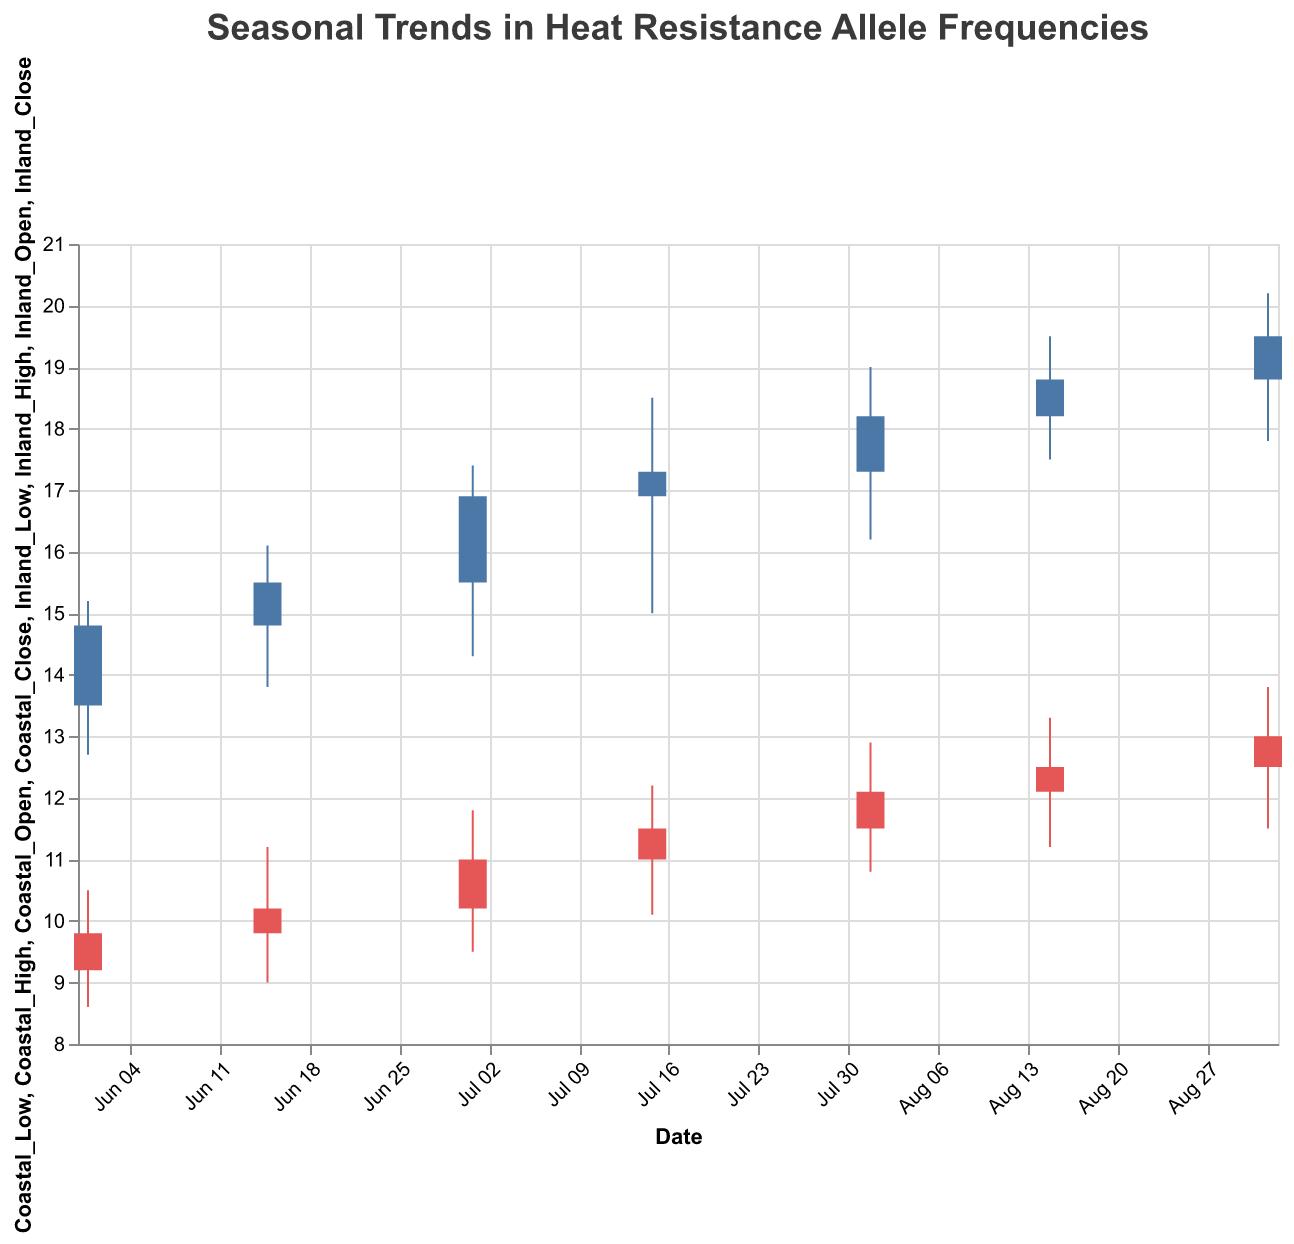What is the title of the figure? The title of the figure is often found at the top center and is designed to give an overview of what the graph represents. Here, the title reads "Seasonal Trends in Heat Resistance Allele Frequencies".
Answer: Seasonal Trends in Heat Resistance Allele Frequencies What colors are used to represent the coastal and inland fish populations? The figure uses different colors to visually distinguish between data sets. The coastal fish population data is represented in blue, and the inland fish population data is represented in red.
Answer: Blue for coastal, red for inland During which date did the coastal fish population have their highest closing value? To find the highest closing value for the coastal fish population, check the Coastal_Close column. The highest value is 19.5, which occurred on 2023-09-01.
Answer: 2023-09-01 What is the trend of allele frequencies in coastal fish from June 1st to September 1st? The coastal allele frequencies, represented by the closing values, show a continuous increase from 14.8 on June 1st to 19.5 on September 1st. This suggests a growing heat resistance over the period.
Answer: Increasing Compare the closing values between coastal and inland fish populations on September 1st. Which population has a higher allele frequency? On September 1st, the closing value for coastal fish is 19.5 and for inland fish is 13.0. Therefore, coastal fish have a higher allele frequency.
Answer: Coastal fish What’s the median closing value of the coastal fish population across all dates? To find the median value, list all the Coastal_Close values: [14.8, 15.5, 16.9, 17.3, 18.2, 18.8, 19.5]. The median is the middle value in this sorted list, which is 17.3.
Answer: 17.3 What is the average closing value for inland fish across all dates? Sum up all the Inland_Close values and divide by the number of dates: (9.8 + 10.2 + 11.0 + 11.5 + 12.1 + 12.5 + 13.0) / 7 = 80.1 / 7 = 11.44.
Answer: 11.44 